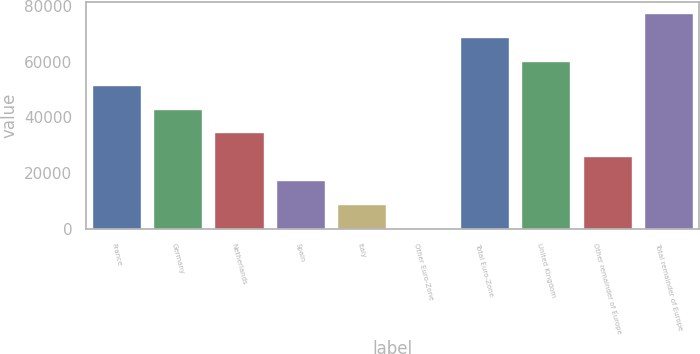Convert chart to OTSL. <chart><loc_0><loc_0><loc_500><loc_500><bar_chart><fcel>France<fcel>Germany<fcel>Netherlands<fcel>Spain<fcel>Italy<fcel>Other Euro-Zone<fcel>Total Euro-Zone<fcel>United Kingdom<fcel>Other remainder of Europe<fcel>Total remainder of Europe<nl><fcel>51761.4<fcel>43185.5<fcel>34609.6<fcel>17457.8<fcel>8881.9<fcel>306<fcel>68913.2<fcel>60337.3<fcel>26033.7<fcel>77489.1<nl></chart> 